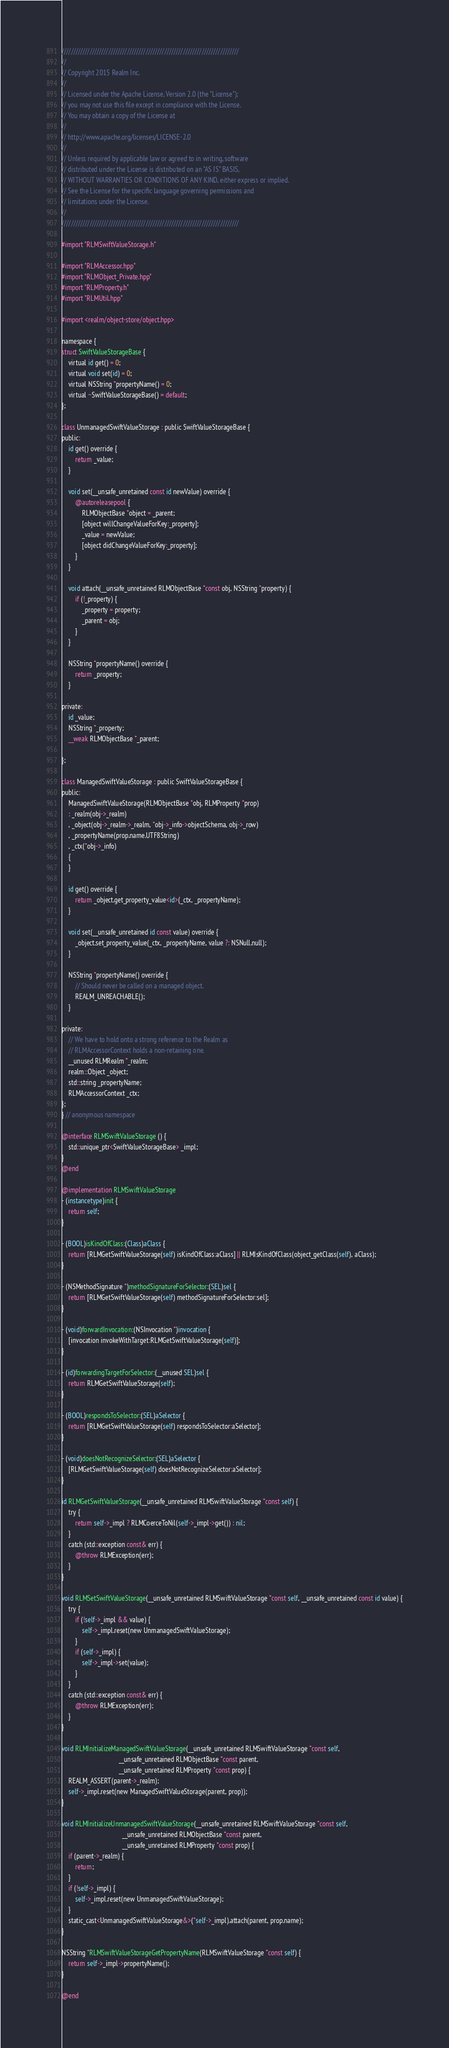Convert code to text. <code><loc_0><loc_0><loc_500><loc_500><_ObjectiveC_>////////////////////////////////////////////////////////////////////////////
//
// Copyright 2015 Realm Inc.
//
// Licensed under the Apache License, Version 2.0 (the "License");
// you may not use this file except in compliance with the License.
// You may obtain a copy of the License at
//
// http://www.apache.org/licenses/LICENSE-2.0
//
// Unless required by applicable law or agreed to in writing, software
// distributed under the License is distributed on an "AS IS" BASIS,
// WITHOUT WARRANTIES OR CONDITIONS OF ANY KIND, either express or implied.
// See the License for the specific language governing permissions and
// limitations under the License.
//
////////////////////////////////////////////////////////////////////////////

#import "RLMSwiftValueStorage.h"

#import "RLMAccessor.hpp"
#import "RLMObject_Private.hpp"
#import "RLMProperty.h"
#import "RLMUtil.hpp"

#import <realm/object-store/object.hpp>

namespace {
struct SwiftValueStorageBase {
    virtual id get() = 0;
    virtual void set(id) = 0;
    virtual NSString *propertyName() = 0;
    virtual ~SwiftValueStorageBase() = default;
};

class UnmanagedSwiftValueStorage : public SwiftValueStorageBase {
public:
    id get() override {
        return _value;
    }

    void set(__unsafe_unretained const id newValue) override {
        @autoreleasepool {
            RLMObjectBase *object = _parent;
            [object willChangeValueForKey:_property];
            _value = newValue;
            [object didChangeValueForKey:_property];
        }
    }

    void attach(__unsafe_unretained RLMObjectBase *const obj, NSString *property) {
        if (!_property) {
            _property = property;
            _parent = obj;
        }
    }

    NSString *propertyName() override {
        return _property;
    }

private:
    id _value;
    NSString *_property;
    __weak RLMObjectBase *_parent;

};

class ManagedSwiftValueStorage : public SwiftValueStorageBase {
public:
    ManagedSwiftValueStorage(RLMObjectBase *obj, RLMProperty *prop)
    : _realm(obj->_realm)
    , _object(obj->_realm->_realm, *obj->_info->objectSchema, obj->_row)
    , _propertyName(prop.name.UTF8String)
    , _ctx(*obj->_info)
    {
    }

    id get() override {
        return _object.get_property_value<id>(_ctx, _propertyName);
    }

    void set(__unsafe_unretained id const value) override {
        _object.set_property_value(_ctx, _propertyName, value ?: NSNull.null);
    }

    NSString *propertyName() override {
        // Should never be called on a managed object.
        REALM_UNREACHABLE();
    }

private:
    // We have to hold onto a strong reference to the Realm as
    // RLMAccessorContext holds a non-retaining one.
    __unused RLMRealm *_realm;
    realm::Object _object;
    std::string _propertyName;
    RLMAccessorContext _ctx;
};
} // anonymous namespace

@interface RLMSwiftValueStorage () {
    std::unique_ptr<SwiftValueStorageBase> _impl;
}
@end

@implementation RLMSwiftValueStorage
- (instancetype)init {
    return self;
}

- (BOOL)isKindOfClass:(Class)aClass {
    return [RLMGetSwiftValueStorage(self) isKindOfClass:aClass] || RLMIsKindOfClass(object_getClass(self), aClass);
}

- (NSMethodSignature *)methodSignatureForSelector:(SEL)sel {
    return [RLMGetSwiftValueStorage(self) methodSignatureForSelector:sel];
}

- (void)forwardInvocation:(NSInvocation *)invocation {
    [invocation invokeWithTarget:RLMGetSwiftValueStorage(self)];
}

- (id)forwardingTargetForSelector:(__unused SEL)sel {
    return RLMGetSwiftValueStorage(self);
}

- (BOOL)respondsToSelector:(SEL)aSelector {
    return [RLMGetSwiftValueStorage(self) respondsToSelector:aSelector];
}

- (void)doesNotRecognizeSelector:(SEL)aSelector {
    [RLMGetSwiftValueStorage(self) doesNotRecognizeSelector:aSelector];
}

id RLMGetSwiftValueStorage(__unsafe_unretained RLMSwiftValueStorage *const self) {
    try {
        return self->_impl ? RLMCoerceToNil(self->_impl->get()) : nil;
    }
    catch (std::exception const& err) {
        @throw RLMException(err);
    }
}

void RLMSetSwiftValueStorage(__unsafe_unretained RLMSwiftValueStorage *const self, __unsafe_unretained const id value) {
    try {
        if (!self->_impl && value) {
            self->_impl.reset(new UnmanagedSwiftValueStorage);
        }
        if (self->_impl) {
            self->_impl->set(value);
        }
    }
    catch (std::exception const& err) {
        @throw RLMException(err);
    }
}

void RLMInitializeManagedSwiftValueStorage(__unsafe_unretained RLMSwiftValueStorage *const self,
                                  __unsafe_unretained RLMObjectBase *const parent,
                                  __unsafe_unretained RLMProperty *const prop) {
    REALM_ASSERT(parent->_realm);
    self->_impl.reset(new ManagedSwiftValueStorage(parent, prop));
}

void RLMInitializeUnmanagedSwiftValueStorage(__unsafe_unretained RLMSwiftValueStorage *const self,
                                    __unsafe_unretained RLMObjectBase *const parent,
                                    __unsafe_unretained RLMProperty *const prop) {
    if (parent->_realm) {
        return;
    }
    if (!self->_impl) {
        self->_impl.reset(new UnmanagedSwiftValueStorage);
    }
    static_cast<UnmanagedSwiftValueStorage&>(*self->_impl).attach(parent, prop.name);
}

NSString *RLMSwiftValueStorageGetPropertyName(RLMSwiftValueStorage *const self) {
    return self->_impl->propertyName();
}

@end
</code> 